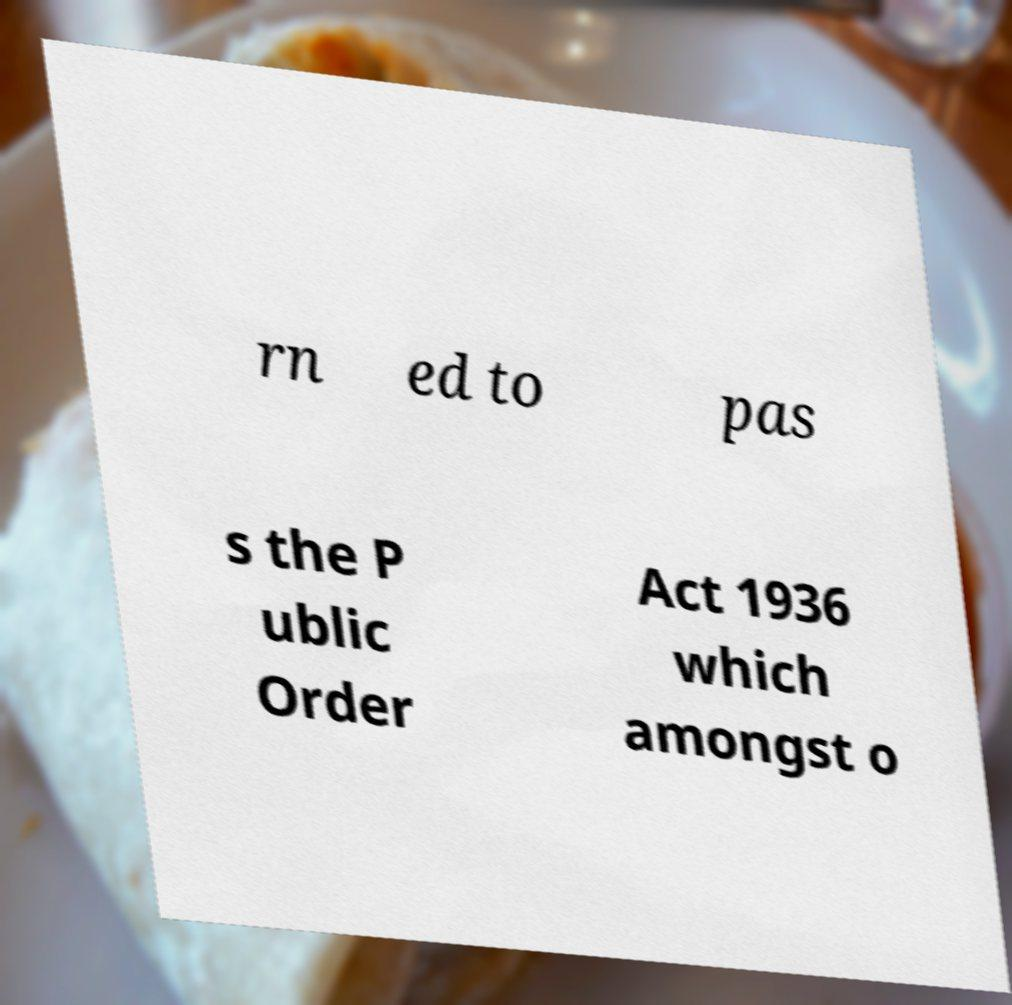What messages or text are displayed in this image? I need them in a readable, typed format. rn ed to pas s the P ublic Order Act 1936 which amongst o 